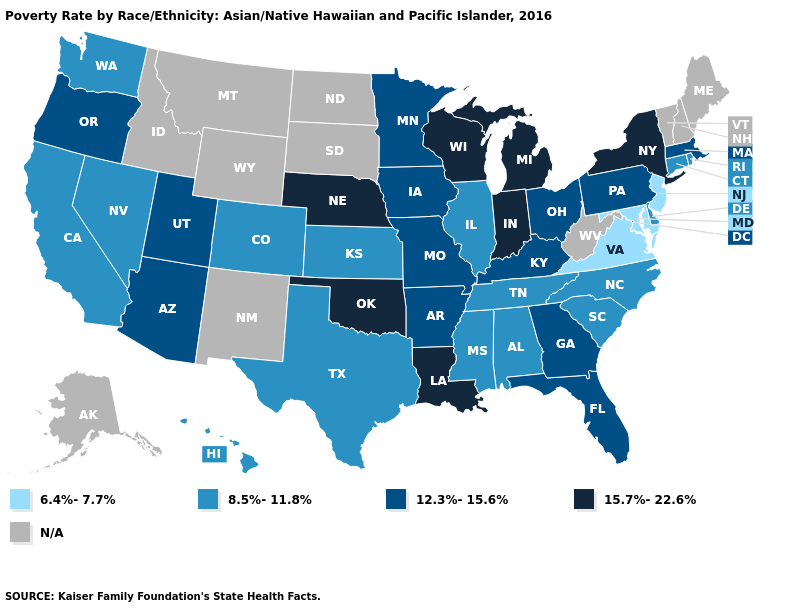Which states have the lowest value in the West?
Keep it brief. California, Colorado, Hawaii, Nevada, Washington. Does Virginia have the lowest value in the South?
Answer briefly. Yes. What is the value of Minnesota?
Answer briefly. 12.3%-15.6%. Name the states that have a value in the range 6.4%-7.7%?
Concise answer only. Maryland, New Jersey, Virginia. What is the highest value in states that border Florida?
Keep it brief. 12.3%-15.6%. Which states hav the highest value in the Northeast?
Keep it brief. New York. What is the lowest value in the USA?
Write a very short answer. 6.4%-7.7%. Among the states that border Nevada , which have the highest value?
Quick response, please. Arizona, Oregon, Utah. What is the value of Massachusetts?
Keep it brief. 12.3%-15.6%. What is the value of Utah?
Short answer required. 12.3%-15.6%. What is the value of Montana?
Keep it brief. N/A. Among the states that border Illinois , which have the lowest value?
Concise answer only. Iowa, Kentucky, Missouri. Which states have the lowest value in the Northeast?
Short answer required. New Jersey. Among the states that border Texas , which have the highest value?
Answer briefly. Louisiana, Oklahoma. 